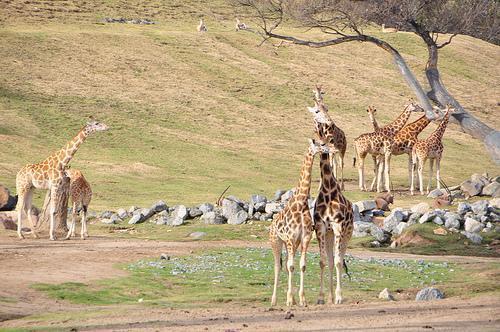How many giraffe are pictured?
Give a very brief answer. 9. How many giraffes are under the tree?
Give a very brief answer. 4. How many giraffe in all?
Give a very brief answer. 9. How many trees are there?
Give a very brief answer. 1. How many giraffes are bent over completely?
Give a very brief answer. 1. 